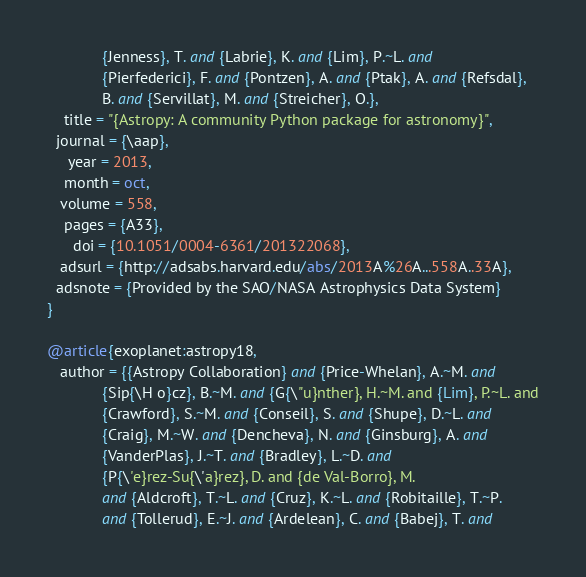<code> <loc_0><loc_0><loc_500><loc_500><_Python_>             {Jenness}, T. and {Labrie}, K. and {Lim}, P.~L. and
             {Pierfederici}, F. and {Pontzen}, A. and {Ptak}, A. and {Refsdal},
             B. and {Servillat}, M. and {Streicher}, O.},
    title = "{Astropy: A community Python package for astronomy}",
  journal = {\aap},
     year = 2013,
    month = oct,
   volume = 558,
    pages = {A33},
      doi = {10.1051/0004-6361/201322068},
   adsurl = {http://adsabs.harvard.edu/abs/2013A%26A...558A..33A},
  adsnote = {Provided by the SAO/NASA Astrophysics Data System}
}

@article{exoplanet:astropy18,
   author = {{Astropy Collaboration} and {Price-Whelan}, A.~M. and
             {Sip{\H o}cz}, B.~M. and {G{\"u}nther}, H.~M. and {Lim}, P.~L. and
             {Crawford}, S.~M. and {Conseil}, S. and {Shupe}, D.~L. and
             {Craig}, M.~W. and {Dencheva}, N. and {Ginsburg}, A. and
             {VanderPlas}, J.~T. and {Bradley}, L.~D. and
             {P{\'e}rez-Su{\'a}rez}, D. and {de Val-Borro}, M.
             and {Aldcroft}, T.~L. and {Cruz}, K.~L. and {Robitaille}, T.~P.
             and {Tollerud}, E.~J. and {Ardelean}, C. and {Babej}, T. and</code> 